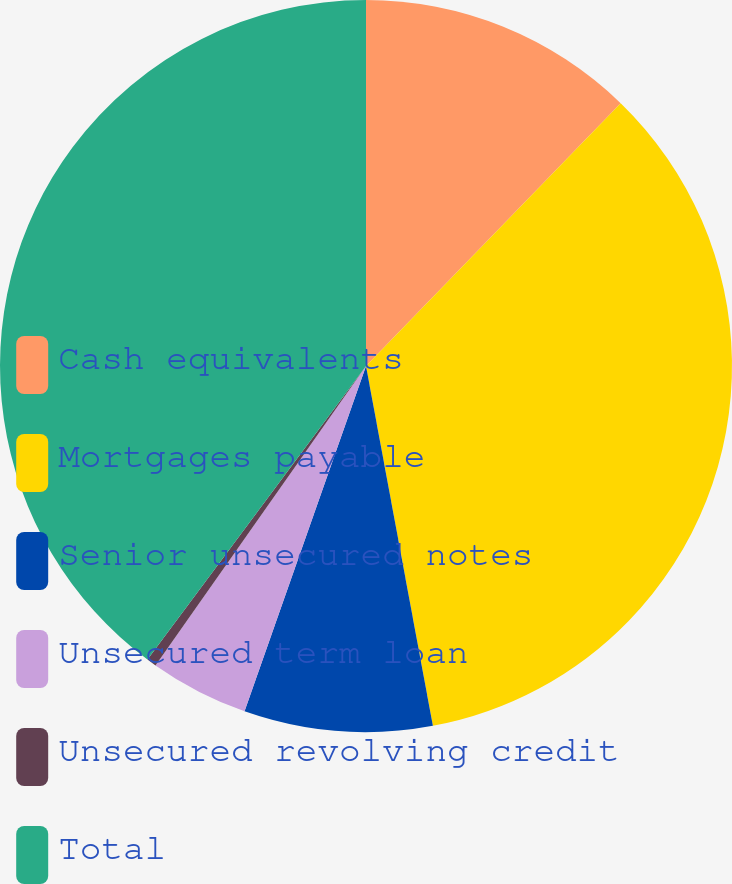<chart> <loc_0><loc_0><loc_500><loc_500><pie_chart><fcel>Cash equivalents<fcel>Mortgages payable<fcel>Senior unsecured notes<fcel>Unsecured term loan<fcel>Unsecured revolving credit<fcel>Total<nl><fcel>12.25%<fcel>34.83%<fcel>8.31%<fcel>4.37%<fcel>0.43%<fcel>39.82%<nl></chart> 